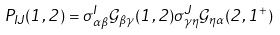Convert formula to latex. <formula><loc_0><loc_0><loc_500><loc_500>P _ { I J } ( 1 , 2 ) = \sigma _ { \alpha \beta } ^ { I } \mathcal { G } _ { \beta \gamma } ( 1 , 2 ) \sigma _ { \gamma \eta } ^ { J } \mathcal { G } _ { \eta \alpha } ( 2 , 1 ^ { + } )</formula> 